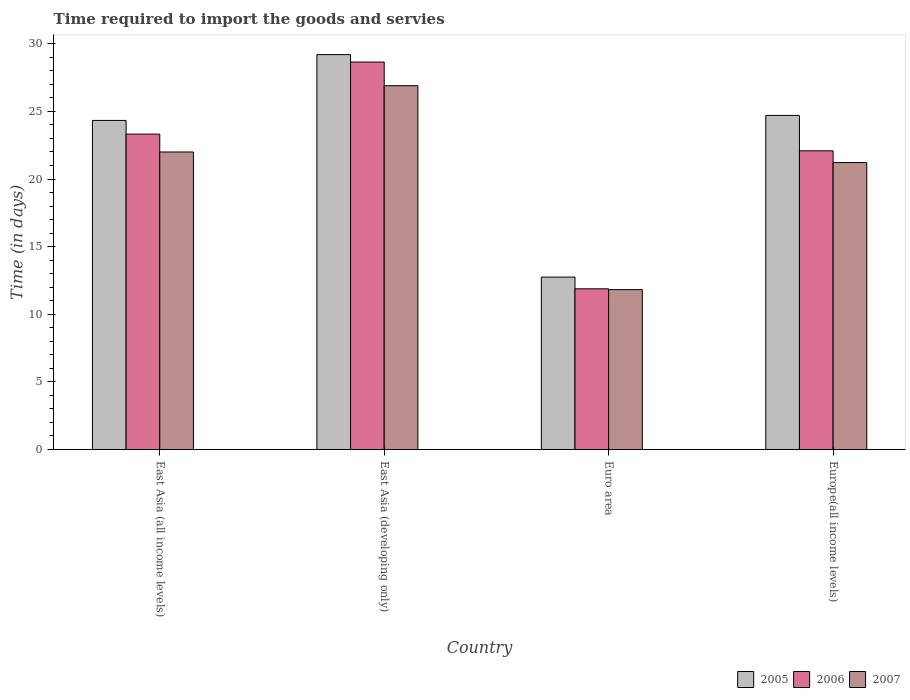How many different coloured bars are there?
Keep it short and to the point. 3. How many groups of bars are there?
Keep it short and to the point. 4. What is the label of the 1st group of bars from the left?
Make the answer very short. East Asia (all income levels). What is the number of days required to import the goods and services in 2005 in Euro area?
Provide a short and direct response. 12.75. Across all countries, what is the maximum number of days required to import the goods and services in 2007?
Offer a very short reply. 26.9. Across all countries, what is the minimum number of days required to import the goods and services in 2005?
Keep it short and to the point. 12.75. In which country was the number of days required to import the goods and services in 2007 maximum?
Ensure brevity in your answer.  East Asia (developing only). In which country was the number of days required to import the goods and services in 2007 minimum?
Your answer should be very brief. Euro area. What is the total number of days required to import the goods and services in 2007 in the graph?
Keep it short and to the point. 81.94. What is the difference between the number of days required to import the goods and services in 2006 in East Asia (all income levels) and that in Europe(all income levels)?
Ensure brevity in your answer.  1.23. What is the difference between the number of days required to import the goods and services in 2006 in Europe(all income levels) and the number of days required to import the goods and services in 2007 in East Asia (all income levels)?
Offer a terse response. 0.09. What is the average number of days required to import the goods and services in 2007 per country?
Make the answer very short. 20.49. What is the difference between the number of days required to import the goods and services of/in 2007 and number of days required to import the goods and services of/in 2006 in Euro area?
Provide a short and direct response. -0.06. What is the ratio of the number of days required to import the goods and services in 2005 in East Asia (all income levels) to that in East Asia (developing only)?
Your answer should be very brief. 0.83. Is the difference between the number of days required to import the goods and services in 2007 in Euro area and Europe(all income levels) greater than the difference between the number of days required to import the goods and services in 2006 in Euro area and Europe(all income levels)?
Offer a very short reply. Yes. What is the difference between the highest and the second highest number of days required to import the goods and services in 2007?
Provide a short and direct response. 5.68. What is the difference between the highest and the lowest number of days required to import the goods and services in 2005?
Ensure brevity in your answer.  16.45. In how many countries, is the number of days required to import the goods and services in 2006 greater than the average number of days required to import the goods and services in 2006 taken over all countries?
Give a very brief answer. 3. Is it the case that in every country, the sum of the number of days required to import the goods and services in 2007 and number of days required to import the goods and services in 2005 is greater than the number of days required to import the goods and services in 2006?
Your response must be concise. Yes. Are all the bars in the graph horizontal?
Provide a succinct answer. No. What is the difference between two consecutive major ticks on the Y-axis?
Provide a succinct answer. 5. Are the values on the major ticks of Y-axis written in scientific E-notation?
Your answer should be very brief. No. Does the graph contain any zero values?
Make the answer very short. No. Does the graph contain grids?
Ensure brevity in your answer.  No. Where does the legend appear in the graph?
Your answer should be compact. Bottom right. How are the legend labels stacked?
Make the answer very short. Horizontal. What is the title of the graph?
Your answer should be compact. Time required to import the goods and servies. Does "2012" appear as one of the legend labels in the graph?
Your answer should be very brief. No. What is the label or title of the X-axis?
Give a very brief answer. Country. What is the label or title of the Y-axis?
Your answer should be very brief. Time (in days). What is the Time (in days) in 2005 in East Asia (all income levels)?
Your answer should be compact. 24.33. What is the Time (in days) in 2006 in East Asia (all income levels)?
Your response must be concise. 23.32. What is the Time (in days) of 2005 in East Asia (developing only)?
Offer a terse response. 29.2. What is the Time (in days) in 2006 in East Asia (developing only)?
Make the answer very short. 28.65. What is the Time (in days) in 2007 in East Asia (developing only)?
Offer a terse response. 26.9. What is the Time (in days) in 2005 in Euro area?
Your response must be concise. 12.75. What is the Time (in days) in 2006 in Euro area?
Provide a short and direct response. 11.88. What is the Time (in days) in 2007 in Euro area?
Your response must be concise. 11.82. What is the Time (in days) of 2005 in Europe(all income levels)?
Offer a terse response. 24.7. What is the Time (in days) of 2006 in Europe(all income levels)?
Keep it short and to the point. 22.09. What is the Time (in days) in 2007 in Europe(all income levels)?
Give a very brief answer. 21.22. Across all countries, what is the maximum Time (in days) of 2005?
Your answer should be very brief. 29.2. Across all countries, what is the maximum Time (in days) of 2006?
Give a very brief answer. 28.65. Across all countries, what is the maximum Time (in days) of 2007?
Provide a succinct answer. 26.9. Across all countries, what is the minimum Time (in days) of 2005?
Provide a short and direct response. 12.75. Across all countries, what is the minimum Time (in days) in 2006?
Offer a very short reply. 11.88. Across all countries, what is the minimum Time (in days) of 2007?
Provide a short and direct response. 11.82. What is the total Time (in days) in 2005 in the graph?
Ensure brevity in your answer.  90.99. What is the total Time (in days) in 2006 in the graph?
Ensure brevity in your answer.  85.94. What is the total Time (in days) of 2007 in the graph?
Give a very brief answer. 81.94. What is the difference between the Time (in days) of 2005 in East Asia (all income levels) and that in East Asia (developing only)?
Ensure brevity in your answer.  -4.87. What is the difference between the Time (in days) in 2006 in East Asia (all income levels) and that in East Asia (developing only)?
Keep it short and to the point. -5.33. What is the difference between the Time (in days) of 2007 in East Asia (all income levels) and that in East Asia (developing only)?
Provide a succinct answer. -4.9. What is the difference between the Time (in days) in 2005 in East Asia (all income levels) and that in Euro area?
Keep it short and to the point. 11.58. What is the difference between the Time (in days) of 2006 in East Asia (all income levels) and that in Euro area?
Your answer should be very brief. 11.44. What is the difference between the Time (in days) of 2007 in East Asia (all income levels) and that in Euro area?
Ensure brevity in your answer.  10.18. What is the difference between the Time (in days) of 2005 in East Asia (all income levels) and that in Europe(all income levels)?
Provide a short and direct response. -0.37. What is the difference between the Time (in days) of 2006 in East Asia (all income levels) and that in Europe(all income levels)?
Provide a short and direct response. 1.23. What is the difference between the Time (in days) of 2007 in East Asia (all income levels) and that in Europe(all income levels)?
Your answer should be compact. 0.78. What is the difference between the Time (in days) of 2005 in East Asia (developing only) and that in Euro area?
Your answer should be very brief. 16.45. What is the difference between the Time (in days) of 2006 in East Asia (developing only) and that in Euro area?
Your response must be concise. 16.77. What is the difference between the Time (in days) of 2007 in East Asia (developing only) and that in Euro area?
Your answer should be very brief. 15.08. What is the difference between the Time (in days) in 2005 in East Asia (developing only) and that in Europe(all income levels)?
Provide a short and direct response. 4.5. What is the difference between the Time (in days) of 2006 in East Asia (developing only) and that in Europe(all income levels)?
Offer a very short reply. 6.56. What is the difference between the Time (in days) in 2007 in East Asia (developing only) and that in Europe(all income levels)?
Offer a terse response. 5.68. What is the difference between the Time (in days) in 2005 in Euro area and that in Europe(all income levels)?
Give a very brief answer. -11.95. What is the difference between the Time (in days) in 2006 in Euro area and that in Europe(all income levels)?
Offer a terse response. -10.2. What is the difference between the Time (in days) of 2007 in Euro area and that in Europe(all income levels)?
Your answer should be very brief. -9.39. What is the difference between the Time (in days) of 2005 in East Asia (all income levels) and the Time (in days) of 2006 in East Asia (developing only)?
Keep it short and to the point. -4.32. What is the difference between the Time (in days) of 2005 in East Asia (all income levels) and the Time (in days) of 2007 in East Asia (developing only)?
Your answer should be compact. -2.57. What is the difference between the Time (in days) of 2006 in East Asia (all income levels) and the Time (in days) of 2007 in East Asia (developing only)?
Provide a succinct answer. -3.58. What is the difference between the Time (in days) in 2005 in East Asia (all income levels) and the Time (in days) in 2006 in Euro area?
Ensure brevity in your answer.  12.45. What is the difference between the Time (in days) in 2005 in East Asia (all income levels) and the Time (in days) in 2007 in Euro area?
Ensure brevity in your answer.  12.51. What is the difference between the Time (in days) of 2006 in East Asia (all income levels) and the Time (in days) of 2007 in Euro area?
Offer a terse response. 11.5. What is the difference between the Time (in days) in 2005 in East Asia (all income levels) and the Time (in days) in 2006 in Europe(all income levels)?
Make the answer very short. 2.25. What is the difference between the Time (in days) of 2005 in East Asia (all income levels) and the Time (in days) of 2007 in Europe(all income levels)?
Give a very brief answer. 3.12. What is the difference between the Time (in days) of 2006 in East Asia (all income levels) and the Time (in days) of 2007 in Europe(all income levels)?
Offer a terse response. 2.1. What is the difference between the Time (in days) of 2005 in East Asia (developing only) and the Time (in days) of 2006 in Euro area?
Keep it short and to the point. 17.32. What is the difference between the Time (in days) in 2005 in East Asia (developing only) and the Time (in days) in 2007 in Euro area?
Provide a succinct answer. 17.38. What is the difference between the Time (in days) in 2006 in East Asia (developing only) and the Time (in days) in 2007 in Euro area?
Your answer should be compact. 16.83. What is the difference between the Time (in days) in 2005 in East Asia (developing only) and the Time (in days) in 2006 in Europe(all income levels)?
Offer a terse response. 7.11. What is the difference between the Time (in days) in 2005 in East Asia (developing only) and the Time (in days) in 2007 in Europe(all income levels)?
Give a very brief answer. 7.98. What is the difference between the Time (in days) of 2006 in East Asia (developing only) and the Time (in days) of 2007 in Europe(all income levels)?
Offer a very short reply. 7.43. What is the difference between the Time (in days) in 2005 in Euro area and the Time (in days) in 2006 in Europe(all income levels)?
Your answer should be compact. -9.34. What is the difference between the Time (in days) of 2005 in Euro area and the Time (in days) of 2007 in Europe(all income levels)?
Provide a short and direct response. -8.47. What is the difference between the Time (in days) in 2006 in Euro area and the Time (in days) in 2007 in Europe(all income levels)?
Provide a succinct answer. -9.34. What is the average Time (in days) in 2005 per country?
Provide a succinct answer. 22.75. What is the average Time (in days) of 2006 per country?
Your response must be concise. 21.49. What is the average Time (in days) of 2007 per country?
Your answer should be compact. 20.49. What is the difference between the Time (in days) of 2005 and Time (in days) of 2006 in East Asia (all income levels)?
Provide a short and direct response. 1.01. What is the difference between the Time (in days) in 2005 and Time (in days) in 2007 in East Asia (all income levels)?
Ensure brevity in your answer.  2.33. What is the difference between the Time (in days) of 2006 and Time (in days) of 2007 in East Asia (all income levels)?
Offer a very short reply. 1.32. What is the difference between the Time (in days) of 2005 and Time (in days) of 2006 in East Asia (developing only)?
Your response must be concise. 0.55. What is the difference between the Time (in days) of 2005 and Time (in days) of 2007 in East Asia (developing only)?
Ensure brevity in your answer.  2.3. What is the difference between the Time (in days) in 2005 and Time (in days) in 2006 in Euro area?
Provide a succinct answer. 0.87. What is the difference between the Time (in days) in 2005 and Time (in days) in 2007 in Euro area?
Offer a very short reply. 0.93. What is the difference between the Time (in days) of 2006 and Time (in days) of 2007 in Euro area?
Make the answer very short. 0.06. What is the difference between the Time (in days) of 2005 and Time (in days) of 2006 in Europe(all income levels)?
Provide a succinct answer. 2.62. What is the difference between the Time (in days) in 2005 and Time (in days) in 2007 in Europe(all income levels)?
Your response must be concise. 3.49. What is the difference between the Time (in days) of 2006 and Time (in days) of 2007 in Europe(all income levels)?
Keep it short and to the point. 0.87. What is the ratio of the Time (in days) of 2006 in East Asia (all income levels) to that in East Asia (developing only)?
Make the answer very short. 0.81. What is the ratio of the Time (in days) in 2007 in East Asia (all income levels) to that in East Asia (developing only)?
Make the answer very short. 0.82. What is the ratio of the Time (in days) of 2005 in East Asia (all income levels) to that in Euro area?
Your answer should be very brief. 1.91. What is the ratio of the Time (in days) in 2006 in East Asia (all income levels) to that in Euro area?
Your answer should be compact. 1.96. What is the ratio of the Time (in days) in 2007 in East Asia (all income levels) to that in Euro area?
Provide a succinct answer. 1.86. What is the ratio of the Time (in days) in 2005 in East Asia (all income levels) to that in Europe(all income levels)?
Keep it short and to the point. 0.98. What is the ratio of the Time (in days) in 2006 in East Asia (all income levels) to that in Europe(all income levels)?
Make the answer very short. 1.06. What is the ratio of the Time (in days) in 2007 in East Asia (all income levels) to that in Europe(all income levels)?
Your response must be concise. 1.04. What is the ratio of the Time (in days) in 2005 in East Asia (developing only) to that in Euro area?
Offer a very short reply. 2.29. What is the ratio of the Time (in days) of 2006 in East Asia (developing only) to that in Euro area?
Your response must be concise. 2.41. What is the ratio of the Time (in days) of 2007 in East Asia (developing only) to that in Euro area?
Keep it short and to the point. 2.28. What is the ratio of the Time (in days) in 2005 in East Asia (developing only) to that in Europe(all income levels)?
Provide a short and direct response. 1.18. What is the ratio of the Time (in days) in 2006 in East Asia (developing only) to that in Europe(all income levels)?
Provide a succinct answer. 1.3. What is the ratio of the Time (in days) in 2007 in East Asia (developing only) to that in Europe(all income levels)?
Make the answer very short. 1.27. What is the ratio of the Time (in days) in 2005 in Euro area to that in Europe(all income levels)?
Your answer should be compact. 0.52. What is the ratio of the Time (in days) of 2006 in Euro area to that in Europe(all income levels)?
Provide a succinct answer. 0.54. What is the ratio of the Time (in days) of 2007 in Euro area to that in Europe(all income levels)?
Give a very brief answer. 0.56. What is the difference between the highest and the second highest Time (in days) in 2005?
Make the answer very short. 4.5. What is the difference between the highest and the second highest Time (in days) in 2006?
Provide a short and direct response. 5.33. What is the difference between the highest and the second highest Time (in days) of 2007?
Your answer should be compact. 4.9. What is the difference between the highest and the lowest Time (in days) of 2005?
Provide a short and direct response. 16.45. What is the difference between the highest and the lowest Time (in days) in 2006?
Your answer should be very brief. 16.77. What is the difference between the highest and the lowest Time (in days) in 2007?
Your response must be concise. 15.08. 